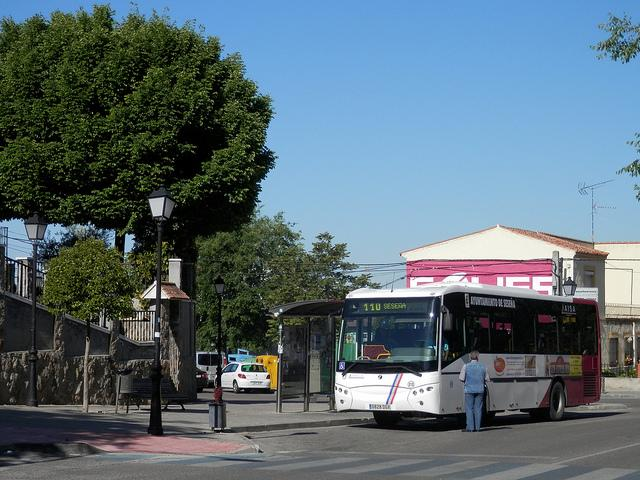During which weather would the bus stop here be most appreciated by riders? rain 